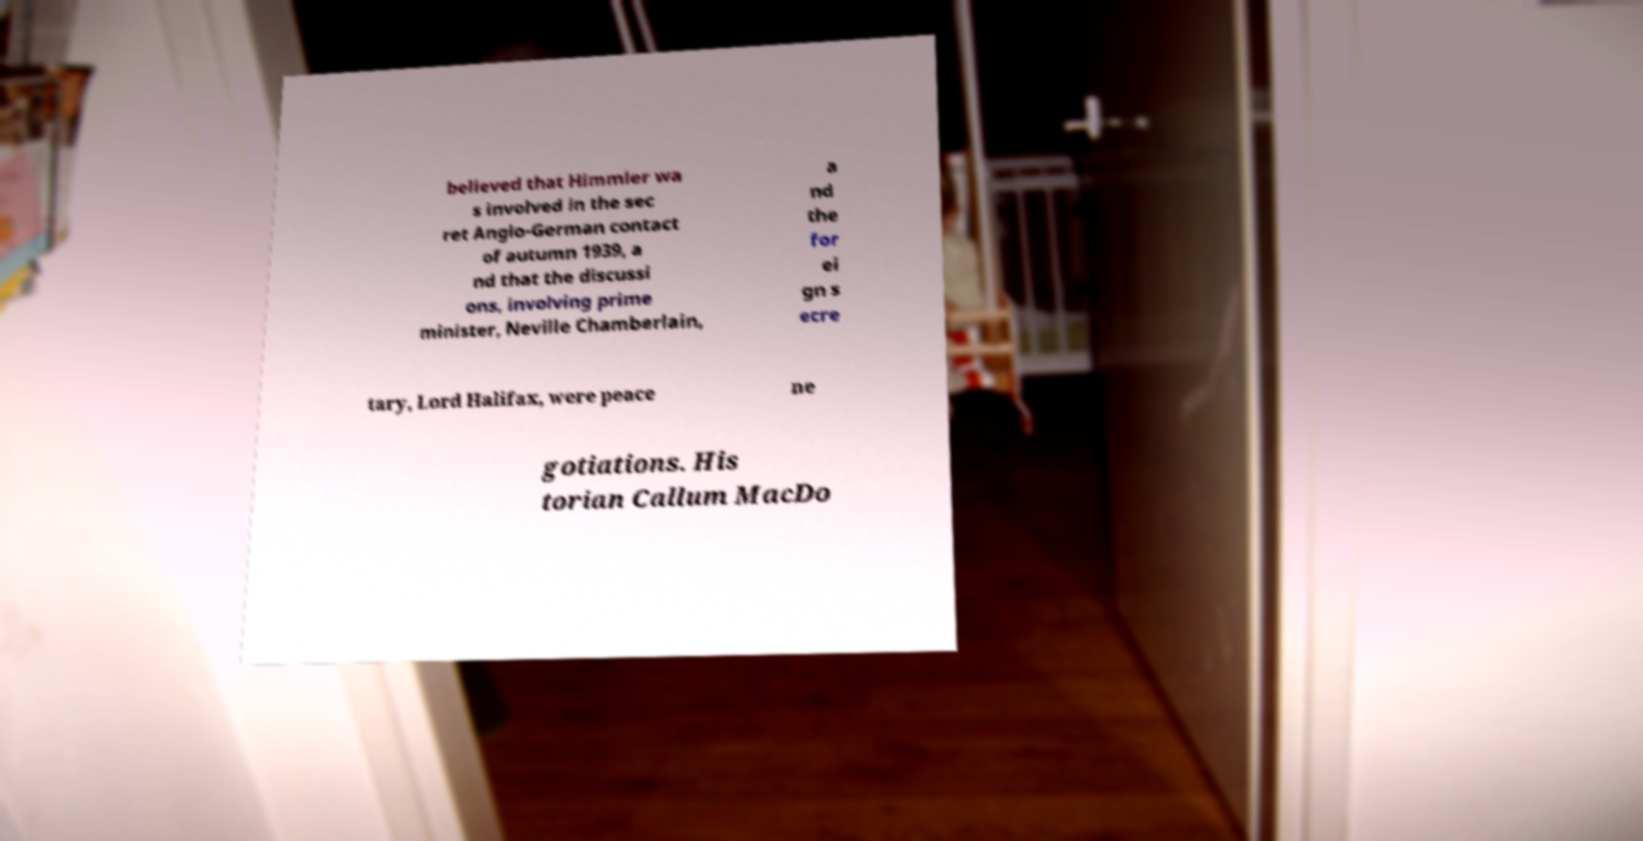For documentation purposes, I need the text within this image transcribed. Could you provide that? believed that Himmler wa s involved in the sec ret Anglo-German contact of autumn 1939, a nd that the discussi ons, involving prime minister, Neville Chamberlain, a nd the for ei gn s ecre tary, Lord Halifax, were peace ne gotiations. His torian Callum MacDo 